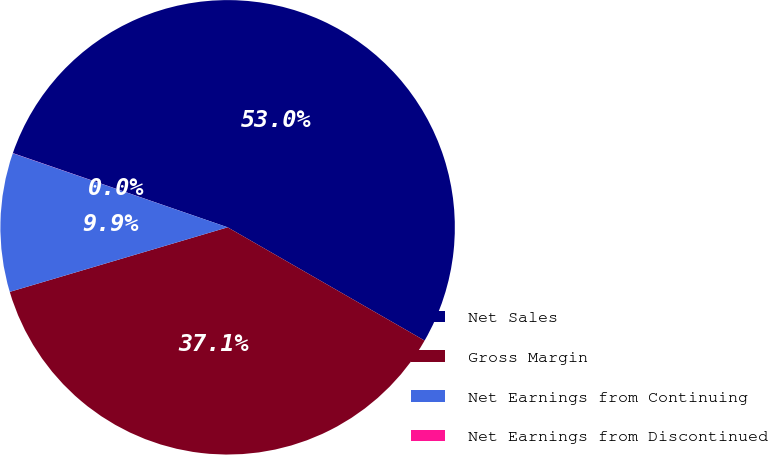<chart> <loc_0><loc_0><loc_500><loc_500><pie_chart><fcel>Net Sales<fcel>Gross Margin<fcel>Net Earnings from Continuing<fcel>Net Earnings from Discontinued<nl><fcel>53.01%<fcel>37.11%<fcel>9.87%<fcel>0.01%<nl></chart> 